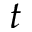Convert formula to latex. <formula><loc_0><loc_0><loc_500><loc_500>t</formula> 